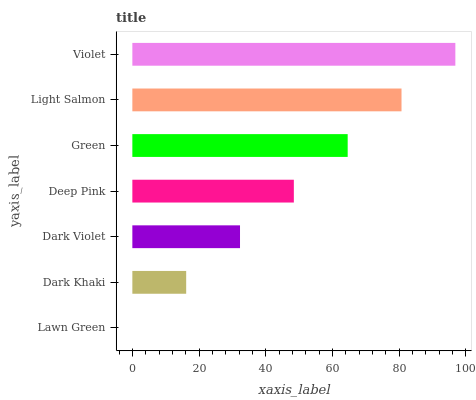Is Lawn Green the minimum?
Answer yes or no. Yes. Is Violet the maximum?
Answer yes or no. Yes. Is Dark Khaki the minimum?
Answer yes or no. No. Is Dark Khaki the maximum?
Answer yes or no. No. Is Dark Khaki greater than Lawn Green?
Answer yes or no. Yes. Is Lawn Green less than Dark Khaki?
Answer yes or no. Yes. Is Lawn Green greater than Dark Khaki?
Answer yes or no. No. Is Dark Khaki less than Lawn Green?
Answer yes or no. No. Is Deep Pink the high median?
Answer yes or no. Yes. Is Deep Pink the low median?
Answer yes or no. Yes. Is Violet the high median?
Answer yes or no. No. Is Violet the low median?
Answer yes or no. No. 